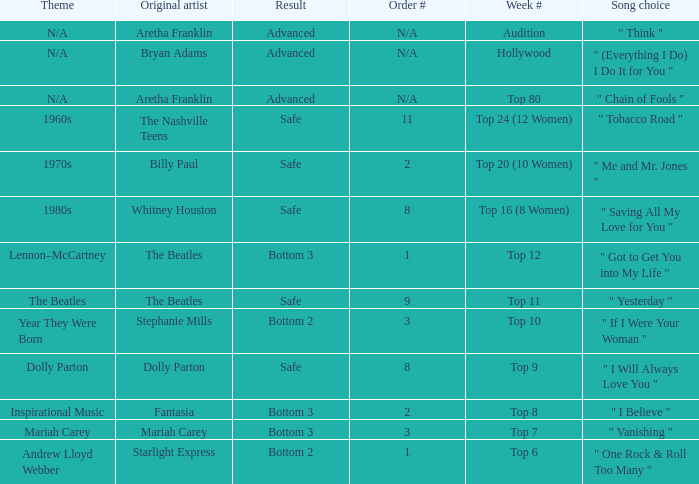Name the week number for andrew lloyd webber Top 6. 